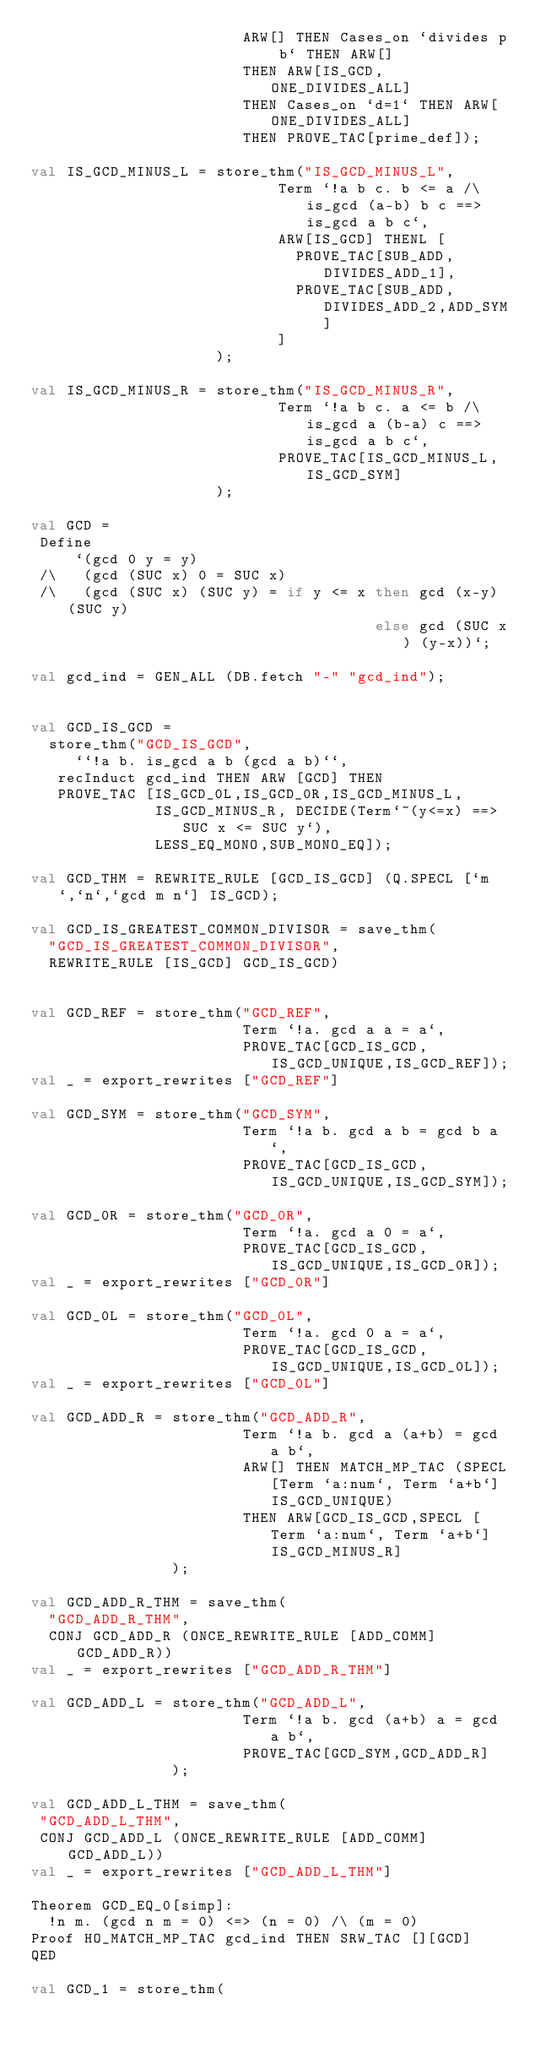<code> <loc_0><loc_0><loc_500><loc_500><_SML_>                        ARW[] THEN Cases_on `divides p b` THEN ARW[]
                        THEN ARW[IS_GCD,ONE_DIVIDES_ALL]
                        THEN Cases_on `d=1` THEN ARW[ONE_DIVIDES_ALL]
                        THEN PROVE_TAC[prime_def]);

val IS_GCD_MINUS_L = store_thm("IS_GCD_MINUS_L",
                            Term `!a b c. b <= a /\ is_gcd (a-b) b c ==> is_gcd a b c`,
                            ARW[IS_GCD] THENL [
                              PROVE_TAC[SUB_ADD,DIVIDES_ADD_1],
                              PROVE_TAC[SUB_ADD,DIVIDES_ADD_2,ADD_SYM]
                            ]
                     );

val IS_GCD_MINUS_R = store_thm("IS_GCD_MINUS_R",
                            Term `!a b c. a <= b /\ is_gcd a (b-a) c ==> is_gcd a b c`,
                            PROVE_TAC[IS_GCD_MINUS_L,IS_GCD_SYM]
                     );

val GCD =
 Define
     `(gcd 0 y = y)
 /\   (gcd (SUC x) 0 = SUC x)
 /\   (gcd (SUC x) (SUC y) = if y <= x then gcd (x-y) (SUC y)
                                       else gcd (SUC x) (y-x))`;

val gcd_ind = GEN_ALL (DB.fetch "-" "gcd_ind");


val GCD_IS_GCD =
  store_thm("GCD_IS_GCD",
     ``!a b. is_gcd a b (gcd a b)``,
   recInduct gcd_ind THEN ARW [GCD] THEN
   PROVE_TAC [IS_GCD_0L,IS_GCD_0R,IS_GCD_MINUS_L,
              IS_GCD_MINUS_R, DECIDE(Term`~(y<=x) ==> SUC x <= SUC y`),
              LESS_EQ_MONO,SUB_MONO_EQ]);

val GCD_THM = REWRITE_RULE [GCD_IS_GCD] (Q.SPECL [`m`,`n`,`gcd m n`] IS_GCD);

val GCD_IS_GREATEST_COMMON_DIVISOR = save_thm(
  "GCD_IS_GREATEST_COMMON_DIVISOR",
  REWRITE_RULE [IS_GCD] GCD_IS_GCD)


val GCD_REF = store_thm("GCD_REF",
                        Term `!a. gcd a a = a`,
                        PROVE_TAC[GCD_IS_GCD,IS_GCD_UNIQUE,IS_GCD_REF]);
val _ = export_rewrites ["GCD_REF"]

val GCD_SYM = store_thm("GCD_SYM",
                        Term `!a b. gcd a b = gcd b a`,
                        PROVE_TAC[GCD_IS_GCD,IS_GCD_UNIQUE,IS_GCD_SYM]);

val GCD_0R = store_thm("GCD_0R",
                        Term `!a. gcd a 0 = a`,
                        PROVE_TAC[GCD_IS_GCD,IS_GCD_UNIQUE,IS_GCD_0R]);
val _ = export_rewrites ["GCD_0R"]

val GCD_0L = store_thm("GCD_0L",
                        Term `!a. gcd 0 a = a`,
                        PROVE_TAC[GCD_IS_GCD,IS_GCD_UNIQUE,IS_GCD_0L]);
val _ = export_rewrites ["GCD_0L"]

val GCD_ADD_R = store_thm("GCD_ADD_R",
                        Term `!a b. gcd a (a+b) = gcd a b`,
                        ARW[] THEN MATCH_MP_TAC (SPECL[Term `a:num`, Term `a+b`] IS_GCD_UNIQUE)
                        THEN ARW[GCD_IS_GCD,SPECL [Term `a:num`, Term `a+b`] IS_GCD_MINUS_R]
                );

val GCD_ADD_R_THM = save_thm(
  "GCD_ADD_R_THM",
  CONJ GCD_ADD_R (ONCE_REWRITE_RULE [ADD_COMM] GCD_ADD_R))
val _ = export_rewrites ["GCD_ADD_R_THM"]

val GCD_ADD_L = store_thm("GCD_ADD_L",
                        Term `!a b. gcd (a+b) a = gcd a b`,
                        PROVE_TAC[GCD_SYM,GCD_ADD_R]
                );

val GCD_ADD_L_THM = save_thm(
 "GCD_ADD_L_THM",
 CONJ GCD_ADD_L (ONCE_REWRITE_RULE [ADD_COMM] GCD_ADD_L))
val _ = export_rewrites ["GCD_ADD_L_THM"]

Theorem GCD_EQ_0[simp]:
  !n m. (gcd n m = 0) <=> (n = 0) /\ (m = 0)
Proof HO_MATCH_MP_TAC gcd_ind THEN SRW_TAC [][GCD]
QED

val GCD_1 = store_thm(</code> 